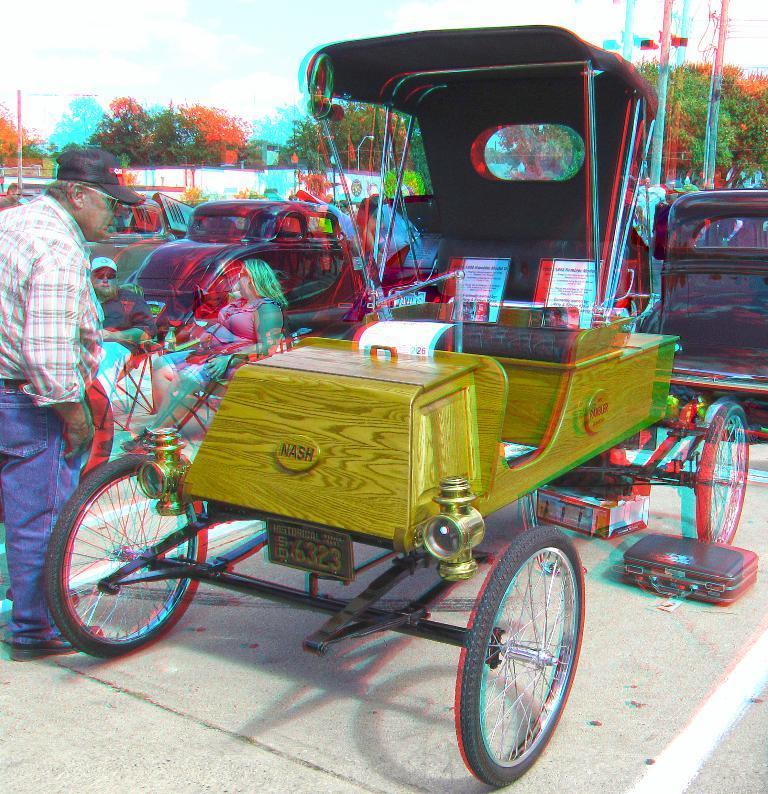Describe this image in one or two sentences. In front of the picture, we see the rickshaw. Beside that, the man is standing. In front of him, we see a man and the women are sitting on chairs. Behind them, we see many vehicles are parked on the road. There are trees, street lights, electric poles, wires and a white wall in the background. At the top, we see the sky. This might be an edited image. 